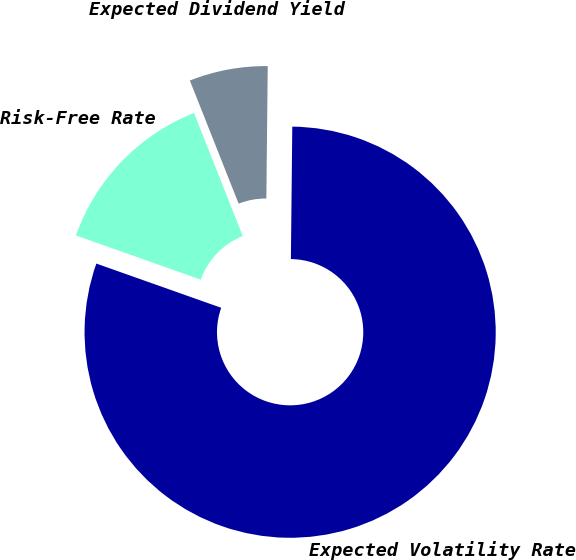<chart> <loc_0><loc_0><loc_500><loc_500><pie_chart><fcel>Expected Volatility Rate<fcel>Risk-Free Rate<fcel>Expected Dividend Yield<nl><fcel>80.25%<fcel>13.58%<fcel>6.17%<nl></chart> 